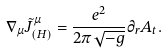Convert formula to latex. <formula><loc_0><loc_0><loc_500><loc_500>\nabla _ { \mu } \tilde { J } ^ { \mu } _ { ( H ) } = \frac { e ^ { 2 } } { 2 \pi \sqrt { - g } } \partial _ { r } A _ { t } . \label a { c o v a r i a n t a n o m a l y }</formula> 